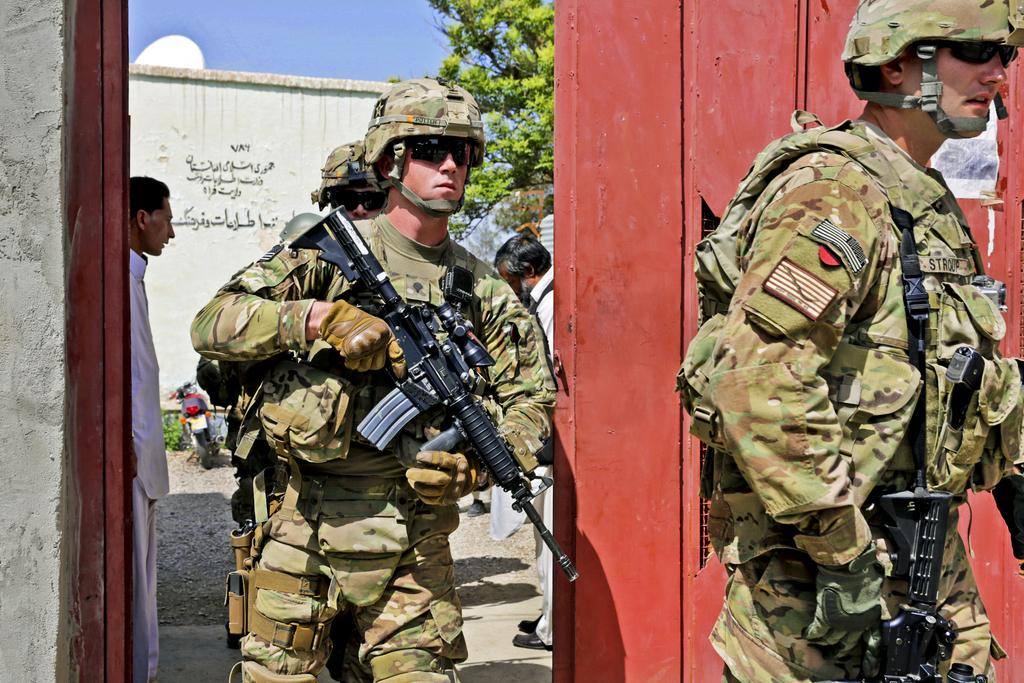What can be seen in the foreground of the image? There are soldiers in the foreground of the image. What are the soldiers holding in their hands? The soldiers are holding guns. What type of headgear are the soldiers wearing? The soldiers are wearing helmets. What is visible in the background of the image? The background of the image is the sky. What is the price of the river in the image? There is no river present in the image, so it is not possible to determine its price. 